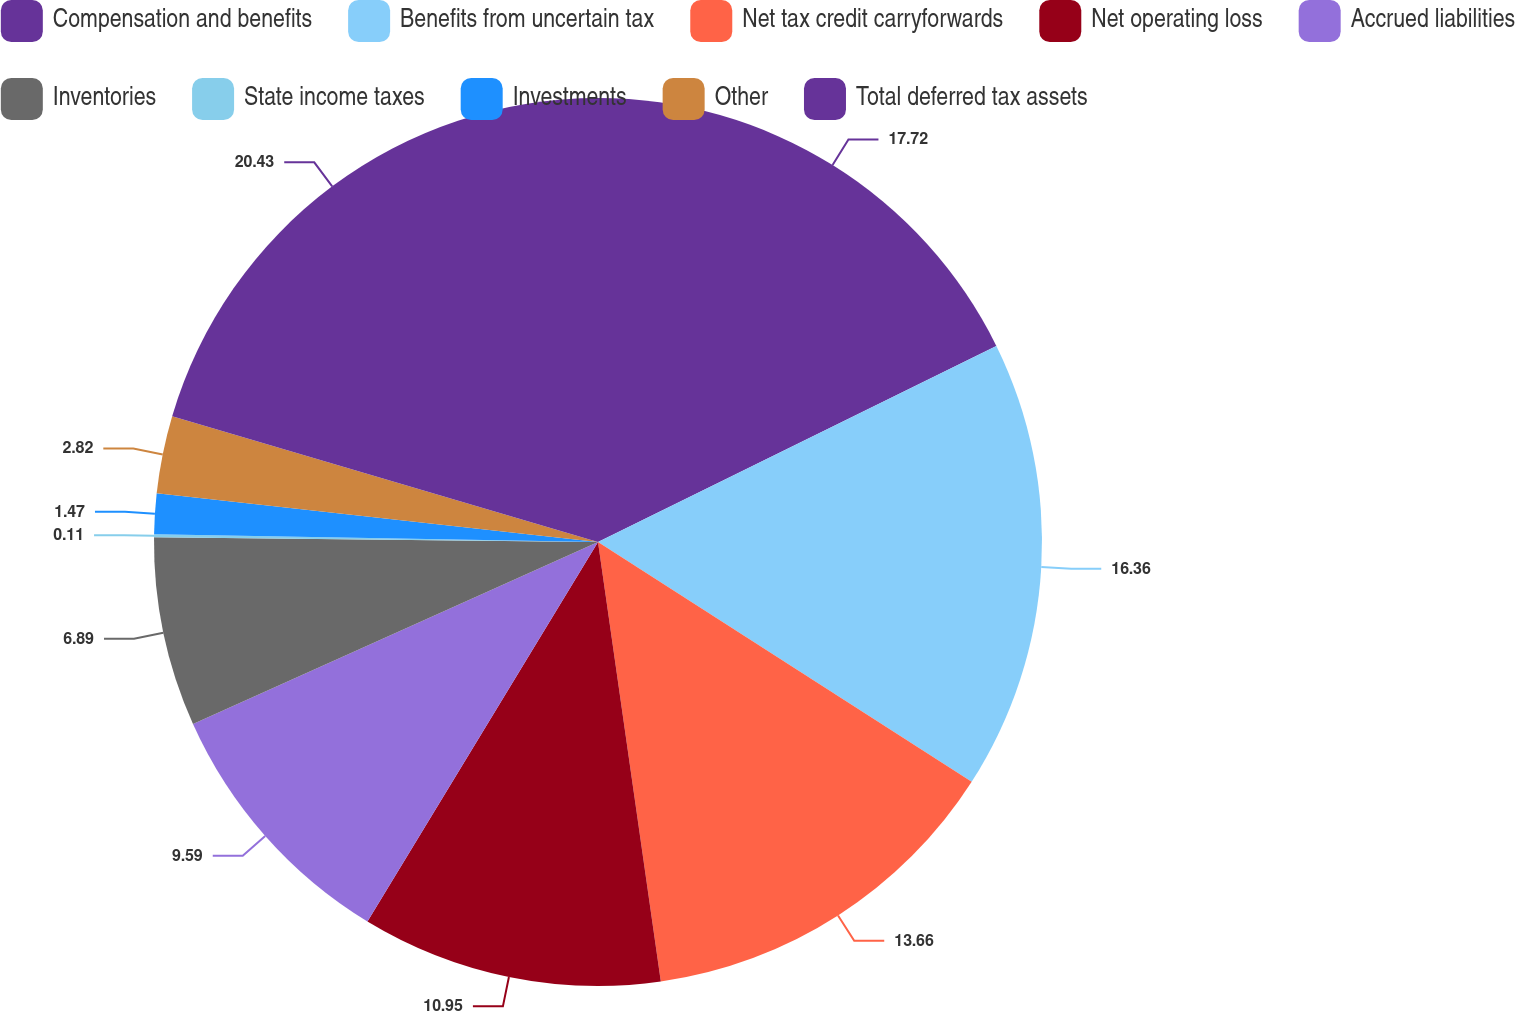<chart> <loc_0><loc_0><loc_500><loc_500><pie_chart><fcel>Compensation and benefits<fcel>Benefits from uncertain tax<fcel>Net tax credit carryforwards<fcel>Net operating loss<fcel>Accrued liabilities<fcel>Inventories<fcel>State income taxes<fcel>Investments<fcel>Other<fcel>Total deferred tax assets<nl><fcel>17.72%<fcel>16.36%<fcel>13.66%<fcel>10.95%<fcel>9.59%<fcel>6.89%<fcel>0.11%<fcel>1.47%<fcel>2.82%<fcel>20.43%<nl></chart> 